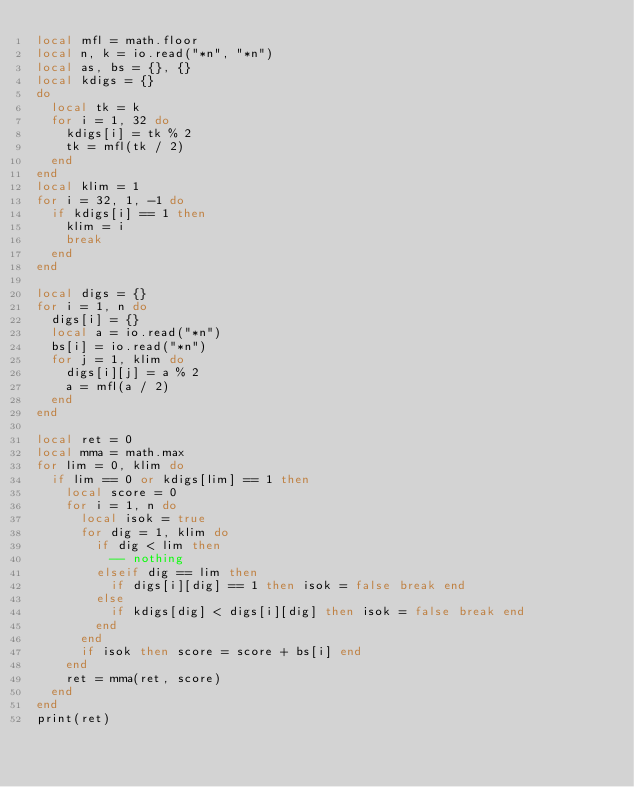Convert code to text. <code><loc_0><loc_0><loc_500><loc_500><_Lua_>local mfl = math.floor
local n, k = io.read("*n", "*n")
local as, bs = {}, {}
local kdigs = {}
do
  local tk = k
  for i = 1, 32 do
    kdigs[i] = tk % 2
    tk = mfl(tk / 2)
  end
end
local klim = 1
for i = 32, 1, -1 do
  if kdigs[i] == 1 then
    klim = i
    break
  end
end

local digs = {}
for i = 1, n do
  digs[i] = {}
  local a = io.read("*n")
  bs[i] = io.read("*n")
  for j = 1, klim do
    digs[i][j] = a % 2
    a = mfl(a / 2)
  end
end

local ret = 0
local mma = math.max
for lim = 0, klim do
  if lim == 0 or kdigs[lim] == 1 then
    local score = 0
    for i = 1, n do
      local isok = true
      for dig = 1, klim do
        if dig < lim then
          -- nothing
        elseif dig == lim then
          if digs[i][dig] == 1 then isok = false break end
        else
          if kdigs[dig] < digs[i][dig] then isok = false break end
        end
      end
      if isok then score = score + bs[i] end
    end
    ret = mma(ret, score)
  end
end
print(ret)
</code> 